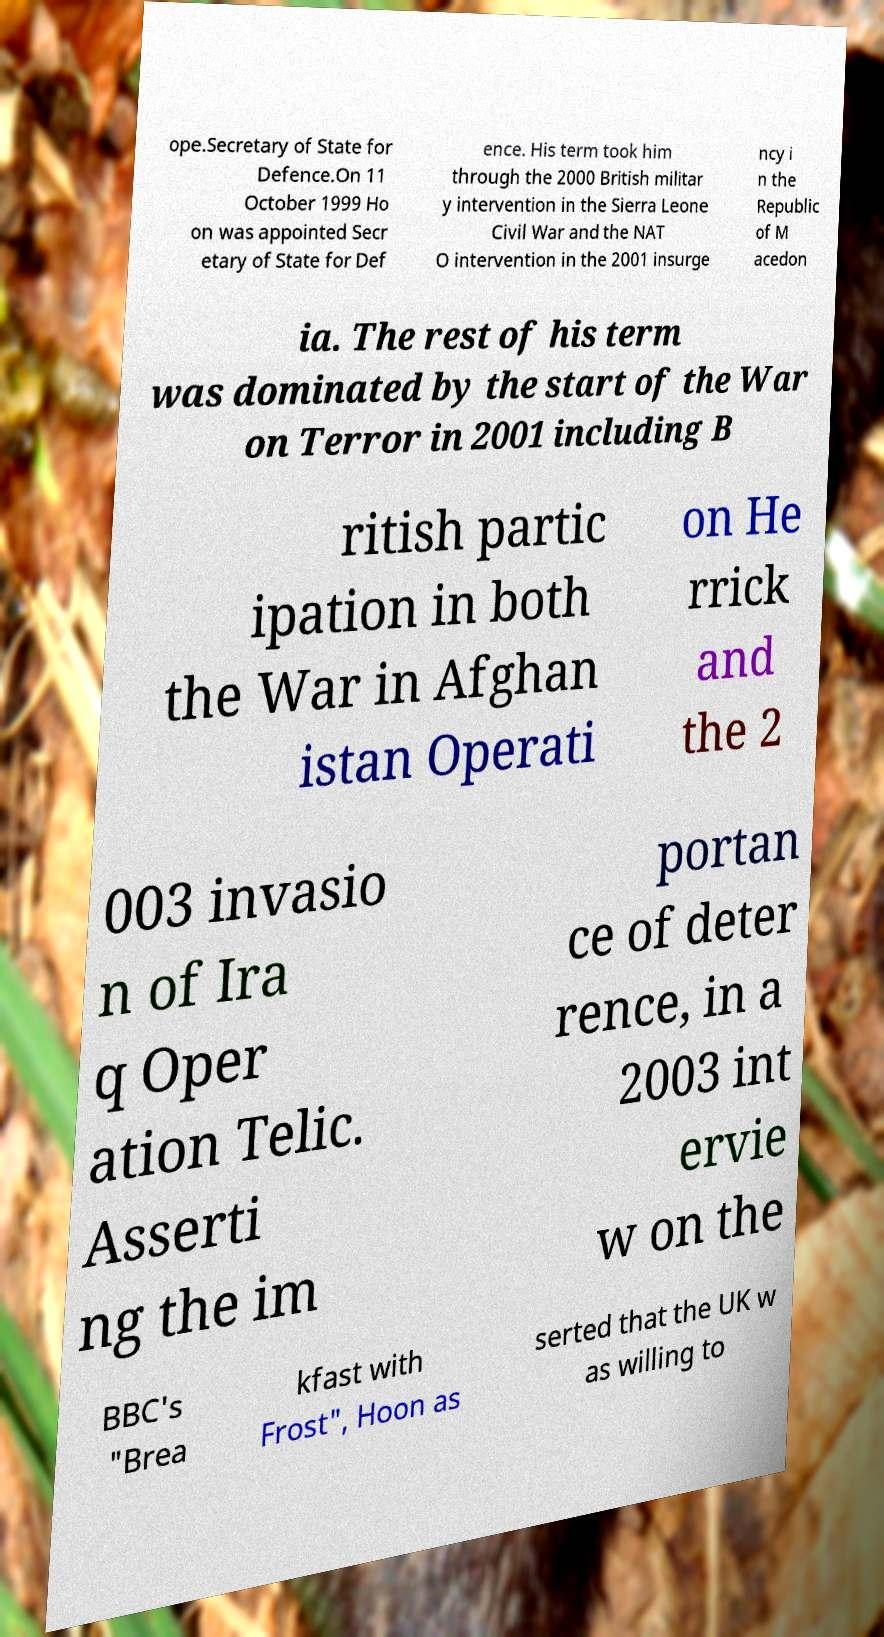Can you read and provide the text displayed in the image?This photo seems to have some interesting text. Can you extract and type it out for me? ope.Secretary of State for Defence.On 11 October 1999 Ho on was appointed Secr etary of State for Def ence. His term took him through the 2000 British militar y intervention in the Sierra Leone Civil War and the NAT O intervention in the 2001 insurge ncy i n the Republic of M acedon ia. The rest of his term was dominated by the start of the War on Terror in 2001 including B ritish partic ipation in both the War in Afghan istan Operati on He rrick and the 2 003 invasio n of Ira q Oper ation Telic. Asserti ng the im portan ce of deter rence, in a 2003 int ervie w on the BBC's "Brea kfast with Frost", Hoon as serted that the UK w as willing to 